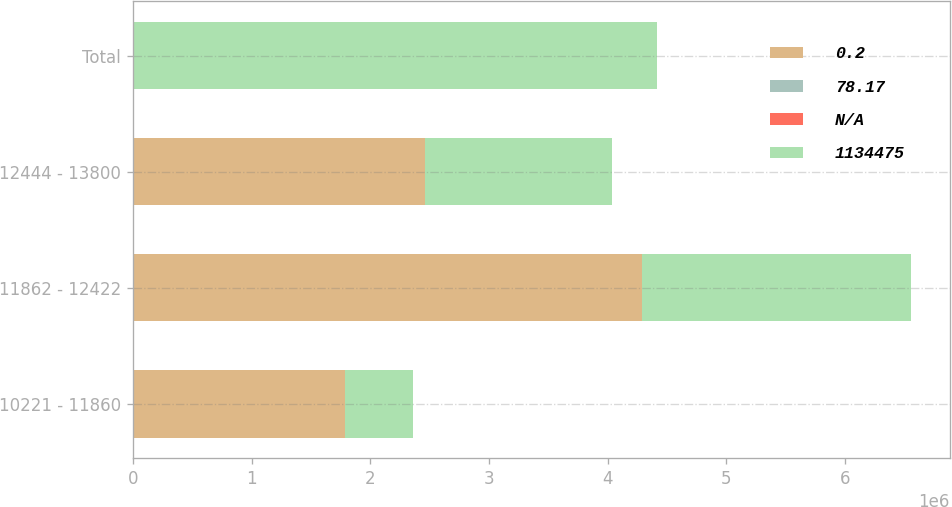Convert chart. <chart><loc_0><loc_0><loc_500><loc_500><stacked_bar_chart><ecel><fcel>10221 - 11860<fcel>11862 - 12422<fcel>12444 - 13800<fcel>Total<nl><fcel>0.2<fcel>1.7888e+06<fcel>4.28869e+06<fcel>2.46282e+06<fcel>124.65<nl><fcel>78.17<fcel>117.14<fcel>119.19<fcel>124.65<fcel>115.39<nl><fcel>nan<fcel>1.3<fcel>3.3<fcel>3.2<fcel>2.6<nl><fcel>1.13448e+06<fcel>572521<fcel>2.26588e+06<fcel>1.57593e+06<fcel>4.41432e+06<nl></chart> 